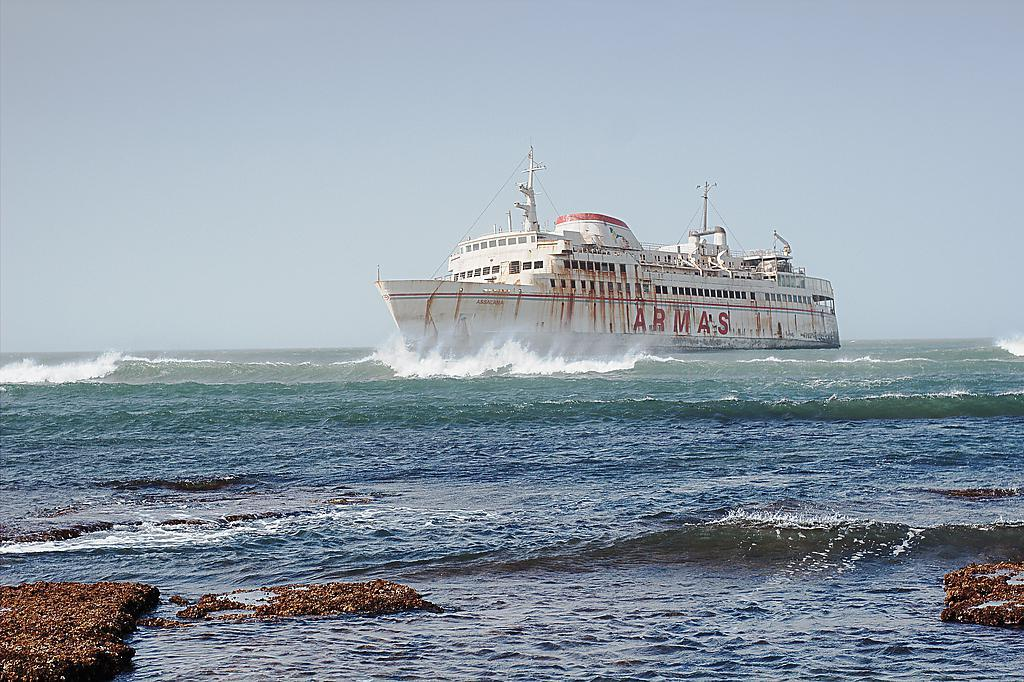What type of natural formation can be seen in the image? There are rocks in the image. What is located on the water in the image? There is a ship on the water in the image. What part of the natural environment is visible in the image? The sky is visible in the background of the image. What type of competition is taking place on the rocks in the image? There is no competition present in the image; it only features rocks and a ship on the water. What is the need for the rocks in the image? The rocks do not have a specific need in the image; they are simply a part of the natural landscape. 